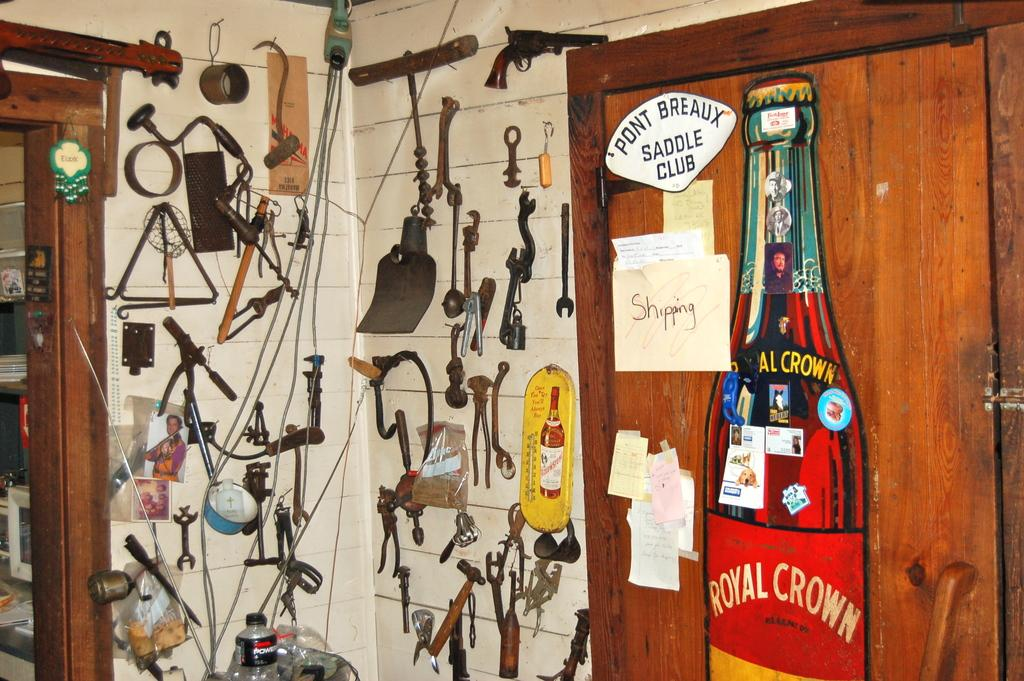<image>
Create a compact narrative representing the image presented. Part of a wall and door are covered in decorations, including a large Royal Crown soda poster on the door. 